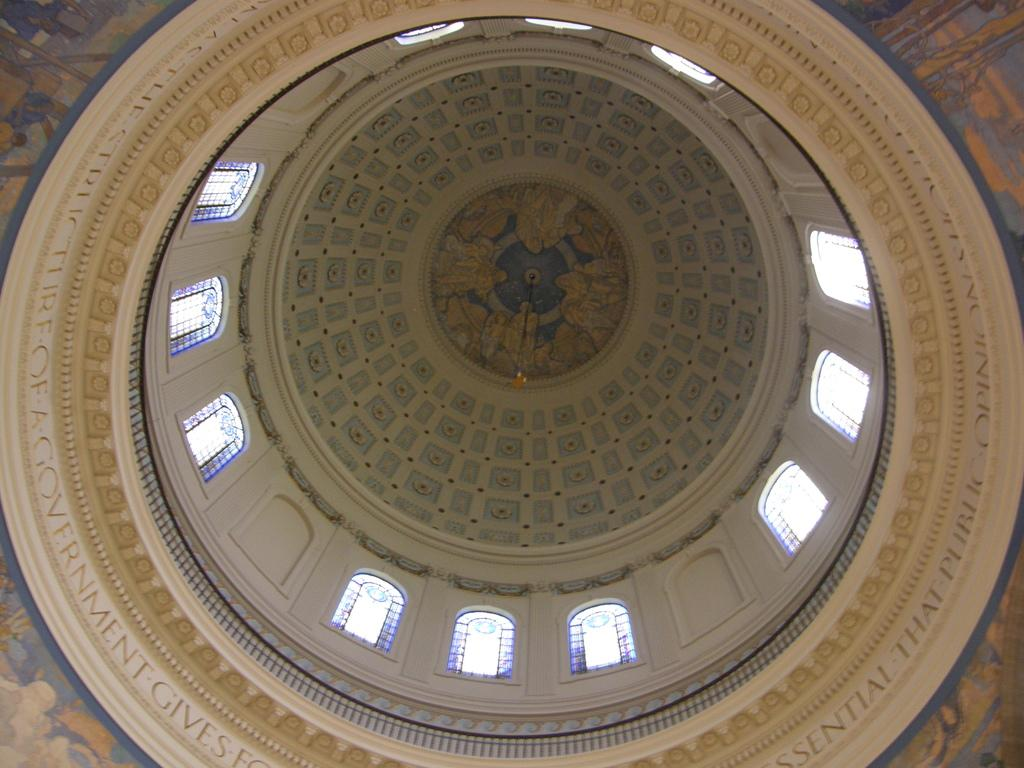What type of location is depicted in the image? The image shows an inside view of a building. Where can text be found in the image? There is text on both the left and right sides of the image. What architectural features are visible in the image? Windows and the ceiling of the building are visible in the image. How does the stomach of the person in the image feel after consuming poison? There is no person or mention of poison in the image; it shows an inside view of a building with text and architectural features. 